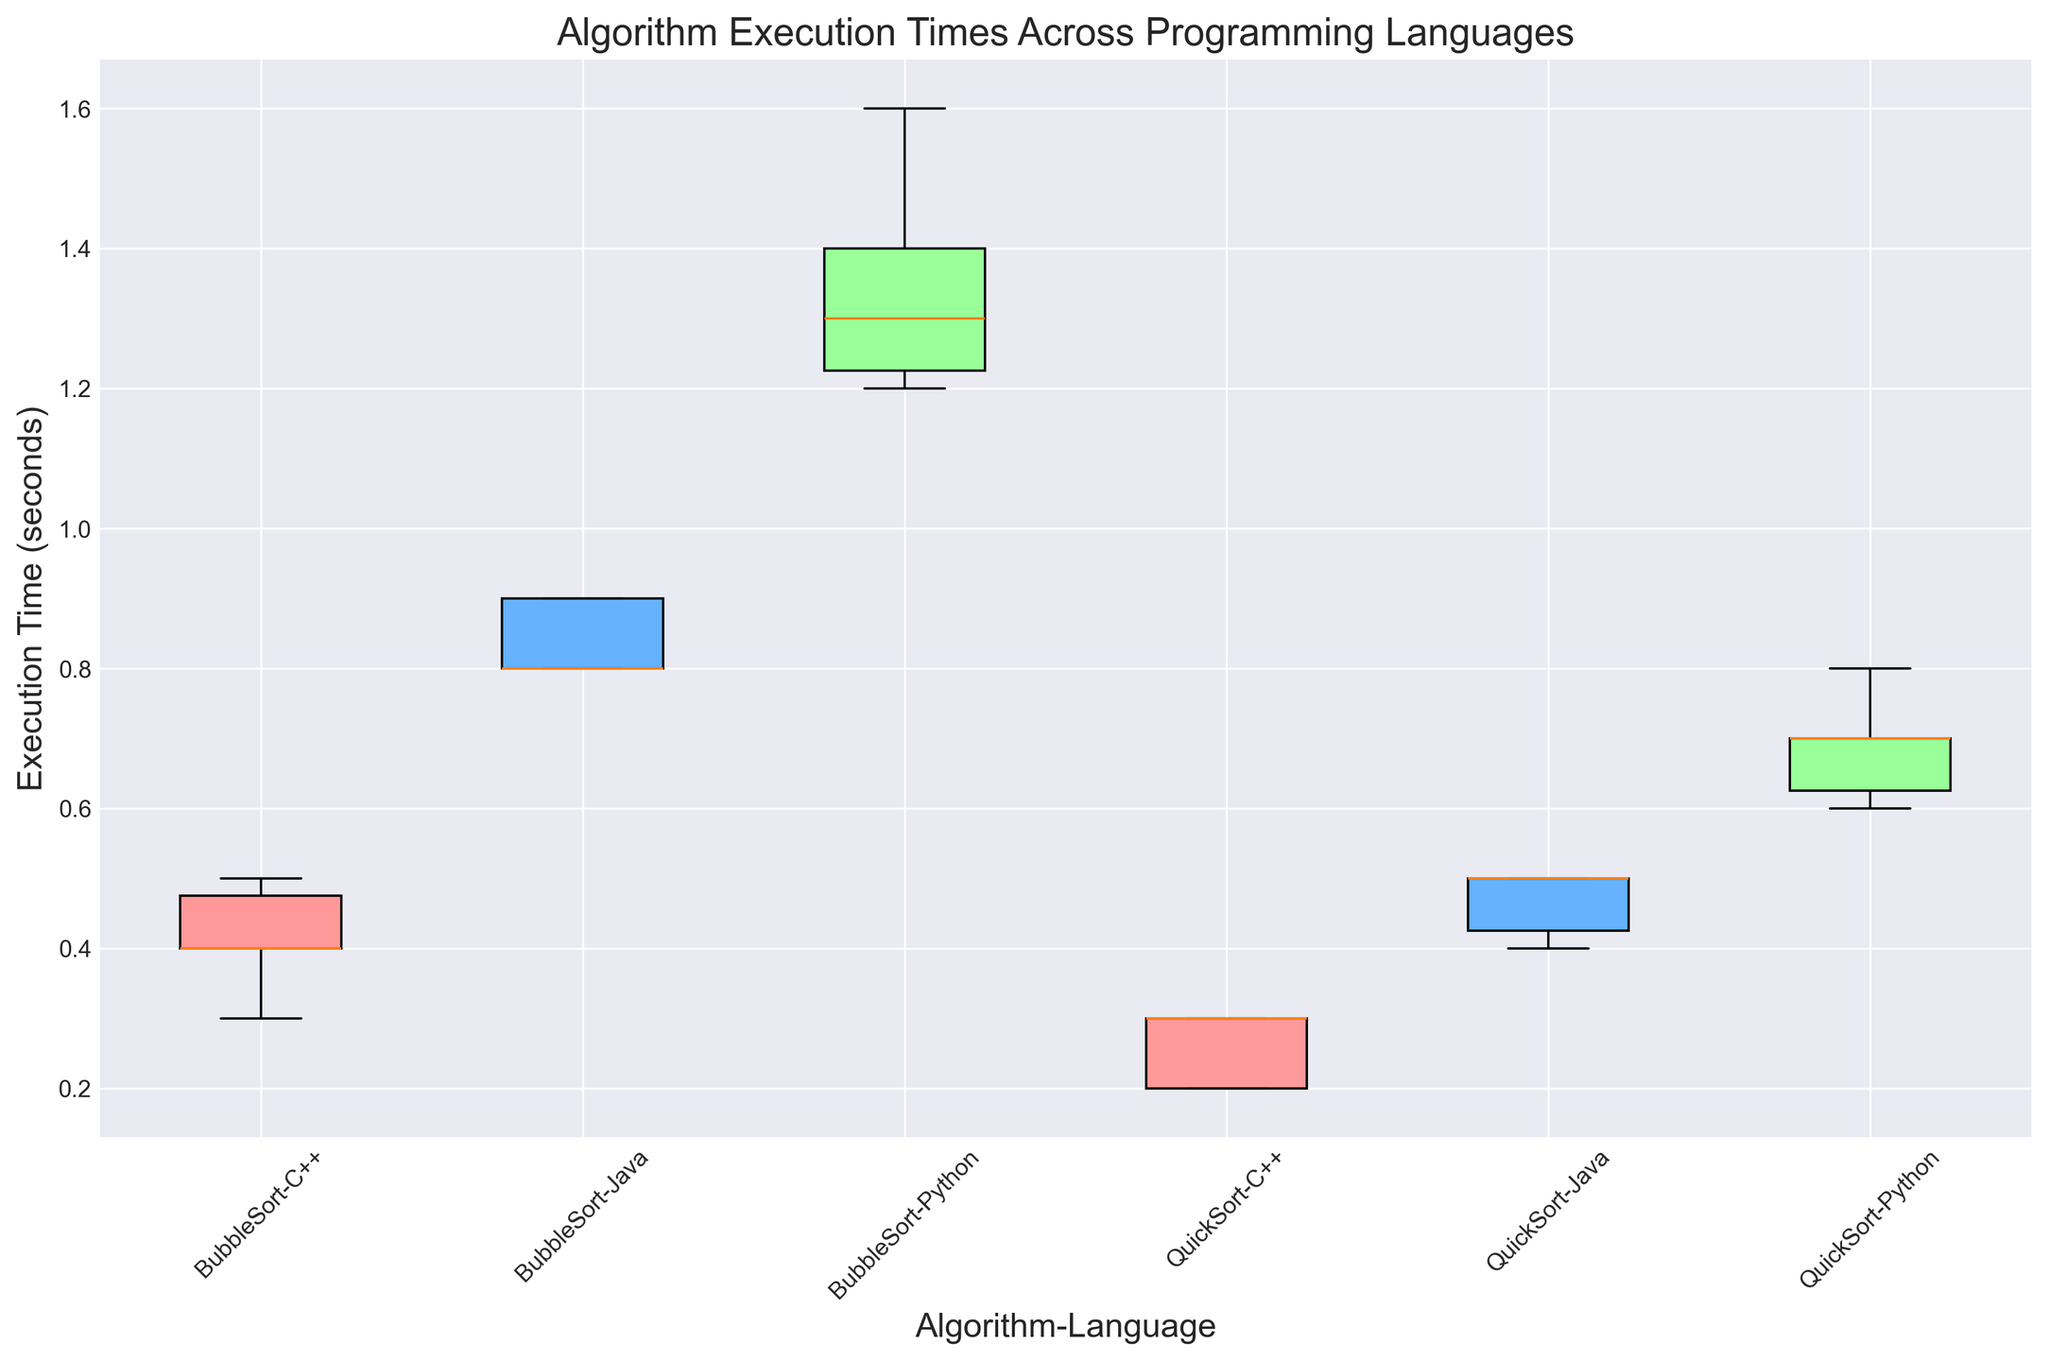Which algorithm-language combination has the highest median execution time? To find the algorithm-language combination with the highest median execution time, look at the box plots and identify the one with the highest median line. For BubbleSort-Python, the median is around 1.3 seconds. For BubbleSort-C++, the median is around 0.4 seconds. For BubbleSort-Java, the median is around 0.8 seconds. For QuickSort-Python, the median is around 0.7 seconds. For QuickSort-C++, the median is around 0.3 seconds. For QuickSort-Java, the median is around 0.5 seconds. The highest median execution time is for BubbleSort-Python.
Answer: BubbleSort-Python Which algorithm and language combination has the smallest range of execution times? To determine the combination with the smallest range, examine the length of the whiskers in each box plot. The range is the difference between the maximum and minimum values. For BubbleSort-Python, the range is 1.6 - 1.2 = 0.4. For BubbleSort-C++, the range is 0.5 - 0.3 = 0.2. For BubbleSort-Java, the range is 0.9 - 0.8 = 0.1. For QuickSort-Python, the range is 0.8 - 0.6 = 0.2. For QuickSort-C++, the range is 0.3 - 0.2 = 0.1. For QuickSort-Java, the range is 0.5 - 0.4 = 0.1. Thus, the combinations with the smallest range are BubbleSort-Java, QuickSort-C++, and QuickSort-Java, all with a range of 0.1.
Answer: BubbleSort-Java, QuickSort-C++, and QuickSort-Java What is the difference in the median execution time between BubbleSort in Python and C++? Find the median values for BubbleSort in Python and C++. The median execution time for BubbleSort-Python is 1.3 seconds. For BubbleSort-C++, the median is 0.4 seconds. Subtract the median value of BubbleSort-C++ from BubbleSort-Python: 1.3 - 0.4 = 0.9 seconds.
Answer: 0.9 seconds Which QuickSort implementation has the highest variation in execution time? To find the QuickSort implementation with the highest variation, look at the interquartile ranges (IQRs) and the length of the whiskers. For QuickSort-Python, the IQR is from 0.6 to 0.7, and the whisker range is from 0.6 to 0.8. For QuickSort-C++, the IQR is from 0.2 to 0.3, and the whisker range is from 0.2 to 0.3. For QuickSort-Java, the IQR is from 0.4 to 0.5, and the whisker range is from 0.4 to 0.5. QuickSort-Python shows the highest variation with a wide spread from 0.6 to 0.8.
Answer: QuickSort-Python What is the median execution time for Java implementations, both for BubbleSort and QuickSort? Look at the median lines for BubbleSort and QuickSort in Java. BubbleSort-Java has a median execution time around 0.8 seconds. QuickSort-Java has a median execution time around 0.5 seconds.
Answer: 0.8 seconds and 0.5 seconds respectively 